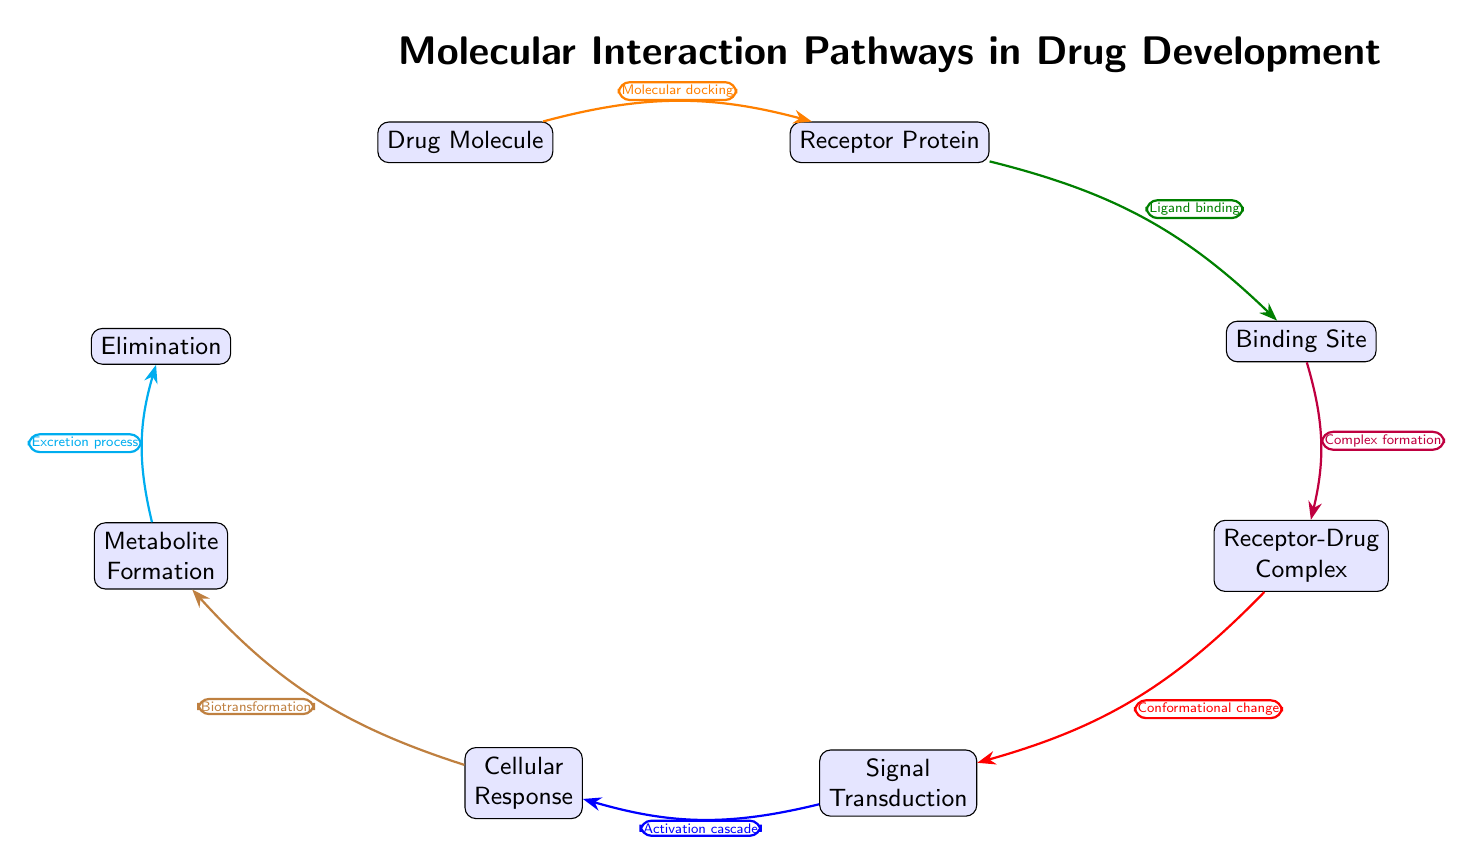What is the first node in the diagram? The first node in the diagram is labeled "Drug Molecule." This can be identified as it is positioned at the far left of the flow, indicating the starting point of the interaction pathways.
Answer: Drug Molecule How many nodes are present in the diagram? To find the total number of nodes, we can count all the distinct elements displayed in the diagram. There are eight nodes labeled from "Drug Molecule" to "Elimination," totaling eight nodes.
Answer: 8 What is the relationship between the "Receptor Protein" and "Binding Site"? The relationship is established by an arrow labeled "Ligand binding," which indicates that the receptor protein interacts with the binding site after the drug molecule is docked at the receptor.
Answer: Ligand binding What is the fourth step in the interaction pathway? Following the sequence from the drug molecule, the fourth step is labeled "Receptor-Drug Complex." This can be determined by tracking the flow of interactions where the drug and receptor form a complex.
Answer: Receptor-Drug Complex What process follows "Signal Transduction"? The process that follows "Signal Transduction" is labeled "Cellular Response." This is the next node in the pathway after a conformational change occurs in the receptor-drug complex, leading to a physiological response.
Answer: Cellular Response What does the "Binding Site" lead to in the diagram? The "Binding Site" leads to the "Receptor-Drug Complex," indicating that after the drug binds to the receptor's binding site, a complex is formed as a result of this interaction.
Answer: Receptor-Drug Complex What is the last step mentioned in the pathway? The last step in the pathway is labeled "Excretion process." This indicates the final outcome of drug metabolism and elimination from the body, following the formation of metabolites.
Answer: Excretion process What type of interaction is starting the process in the diagram? The interaction that starts the process is termed "Molecular docking," which signifies the initial step of the drug molecule engaging with the receptor protein.
Answer: Molecular docking What color arrow indicates "Complex formation"? The arrow indicating "Complex formation" is colored purple. The specific color can be recognized by observing the arrow directly linking the "Binding Site" and "Receptor-Drug Complex."
Answer: purple 